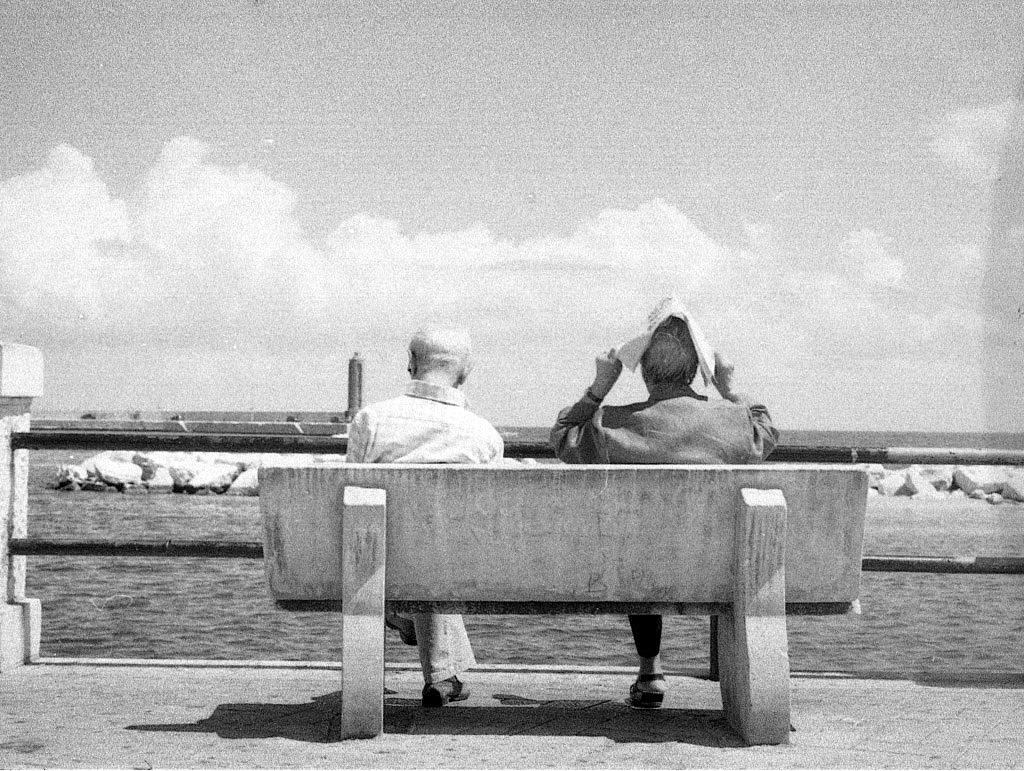How many people are sitting in the image? There are two persons sitting on chairs in the image. What can be seen in the background of the image? The background of the image includes the sky. What natural feature is visible at the bottom of the image? There is a river visible in the bottom of the image. What type of terrain is near the river? There are stones present near the river. What type of authority is represented by the nation in the image? There is no nation or authority present in the image; it only features two persons sitting on chairs, a sky background, a river, and stones near the river. 